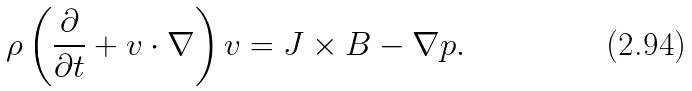Convert formula to latex. <formula><loc_0><loc_0><loc_500><loc_500>\rho \left ( { \frac { \partial } { \partial t } } + v \cdot \nabla \right ) v = J \times B - \nabla p .</formula> 